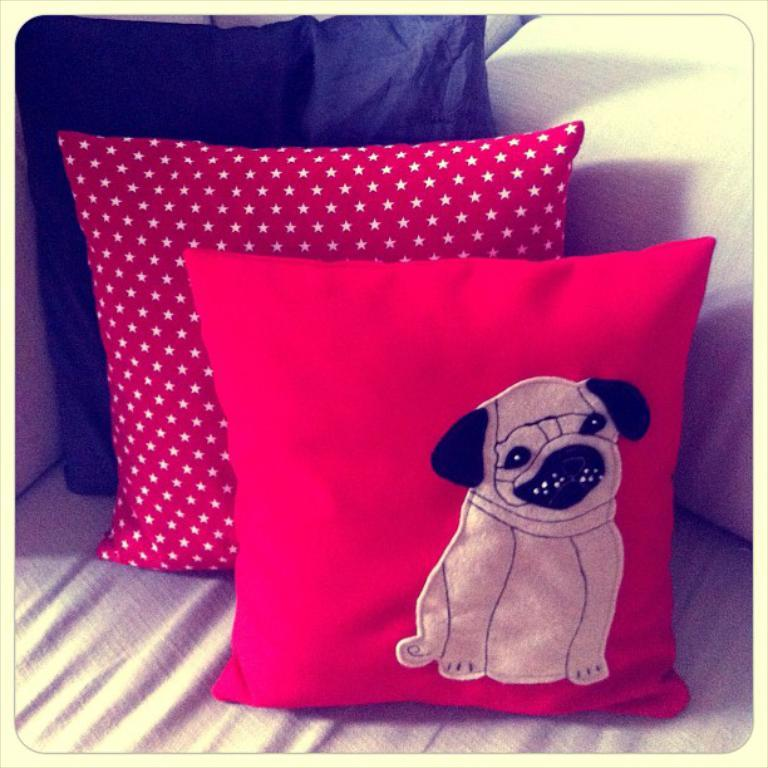How many cushions are visible in the image? There are three cushions in the image. Where are the cushions located? The cushions are on a couch. What design or image is present on one of the cushions? There is a dog image on one of the cushions. What route does the hen take to reach the other cushions in the image? There is no hen present in the image, so it cannot be determined what route it might take. 